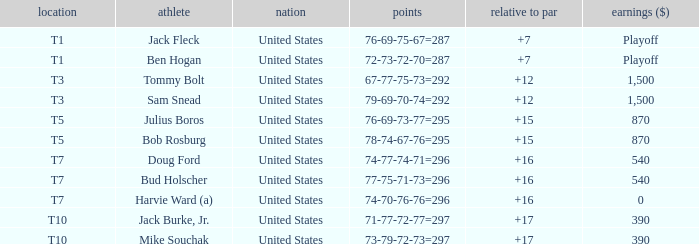Which money has player Jack Fleck with t1 place? Playoff. 